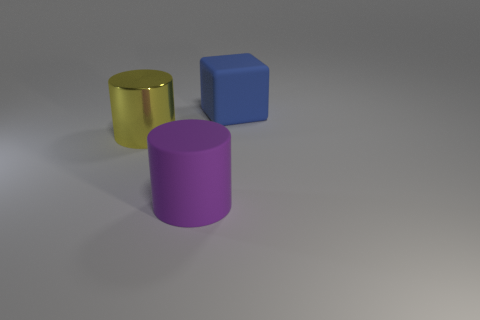Is there any other thing that has the same material as the yellow thing?
Ensure brevity in your answer.  No. What is the material of the block behind the shiny thing left of the big cylinder to the right of the shiny cylinder?
Give a very brief answer. Rubber. There is a rubber thing that is behind the matte cylinder; is it the same color as the large matte cylinder?
Offer a very short reply. No. What shape is the rubber thing on the left side of the big object right of the matte object that is on the left side of the large cube?
Keep it short and to the point. Cylinder. How many large purple matte things are in front of the thing that is behind the big metallic object?
Offer a very short reply. 1. Are the large purple thing and the big yellow thing made of the same material?
Your response must be concise. No. There is a big matte object that is on the left side of the large rubber thing that is to the right of the large purple object; how many large yellow shiny things are on the left side of it?
Your answer should be very brief. 1. The object in front of the big yellow metallic object is what color?
Your answer should be compact. Purple. There is a rubber thing that is right of the large cylinder in front of the large metal object; what is its shape?
Ensure brevity in your answer.  Cube. Do the big matte cylinder and the metal cylinder have the same color?
Offer a very short reply. No. 